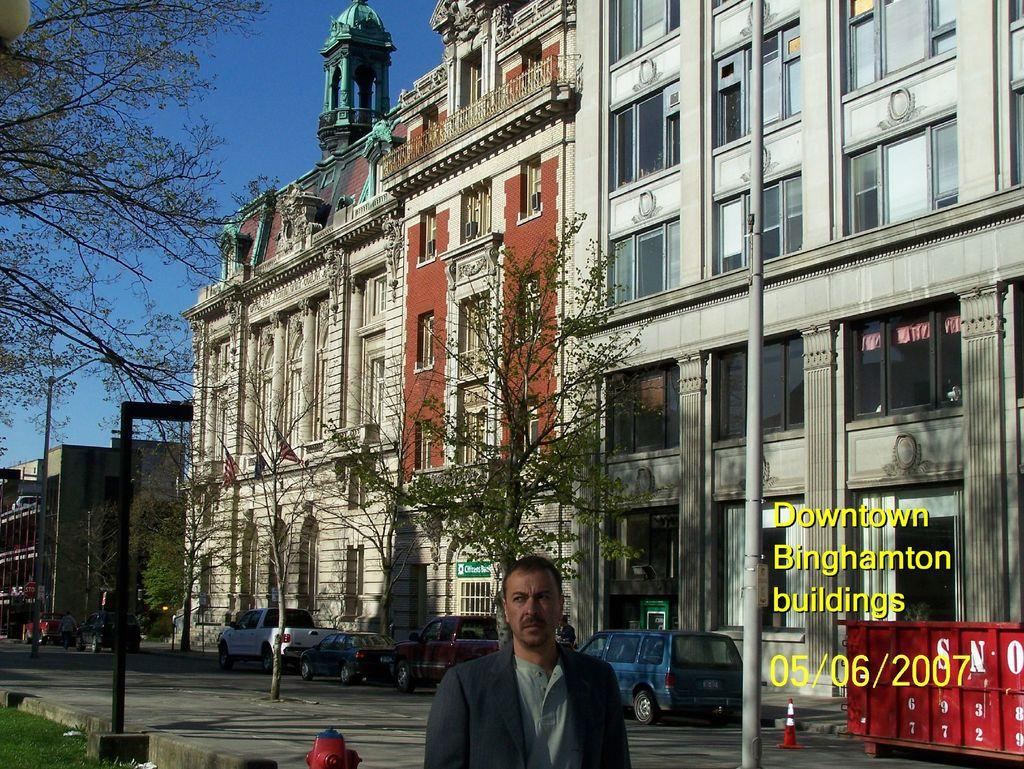Who is present in the image? There is a man in the image. What type of natural environment can be seen in the image? There are trees and grass in the image. What type of man-made structures are visible in the image? There are buildings in the image. What is the man interacting with in the image? The man is interacting with objects in the image. What is visible in the background of the image? The sky is visible in the image. What can be seen on the right side of the image? There are texts and a date on the right side of the image. What type of kite is the man flying in the image? There is no kite present in the image. How many legs does the man have in the image? The man has two legs in the image. However, this question is absurd because it is not relevant to the image and the man's legs are not a focus of the image. 